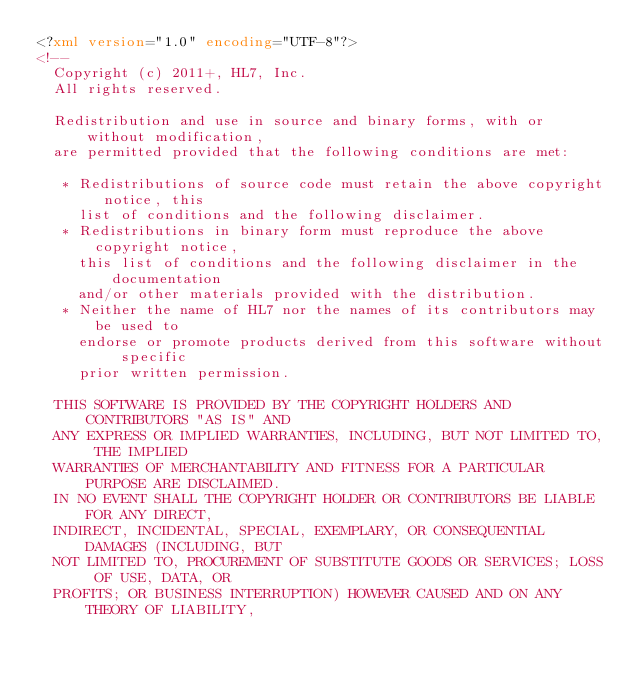Convert code to text. <code><loc_0><loc_0><loc_500><loc_500><_XML_><?xml version="1.0" encoding="UTF-8"?>
<!-- 
  Copyright (c) 2011+, HL7, Inc.
  All rights reserved.
  
  Redistribution and use in source and binary forms, with or without modification, 
  are permitted provided that the following conditions are met:
  
   * Redistributions of source code must retain the above copyright notice, this 
     list of conditions and the following disclaimer.
   * Redistributions in binary form must reproduce the above copyright notice, 
     this list of conditions and the following disclaimer in the documentation 
     and/or other materials provided with the distribution.
   * Neither the name of HL7 nor the names of its contributors may be used to 
     endorse or promote products derived from this software without specific 
     prior written permission.
  
  THIS SOFTWARE IS PROVIDED BY THE COPYRIGHT HOLDERS AND CONTRIBUTORS "AS IS" AND 
  ANY EXPRESS OR IMPLIED WARRANTIES, INCLUDING, BUT NOT LIMITED TO, THE IMPLIED 
  WARRANTIES OF MERCHANTABILITY AND FITNESS FOR A PARTICULAR PURPOSE ARE DISCLAIMED. 
  IN NO EVENT SHALL THE COPYRIGHT HOLDER OR CONTRIBUTORS BE LIABLE FOR ANY DIRECT, 
  INDIRECT, INCIDENTAL, SPECIAL, EXEMPLARY, OR CONSEQUENTIAL DAMAGES (INCLUDING, BUT 
  NOT LIMITED TO, PROCUREMENT OF SUBSTITUTE GOODS OR SERVICES; LOSS OF USE, DATA, OR 
  PROFITS; OR BUSINESS INTERRUPTION) HOWEVER CAUSED AND ON ANY THEORY OF LIABILITY, </code> 